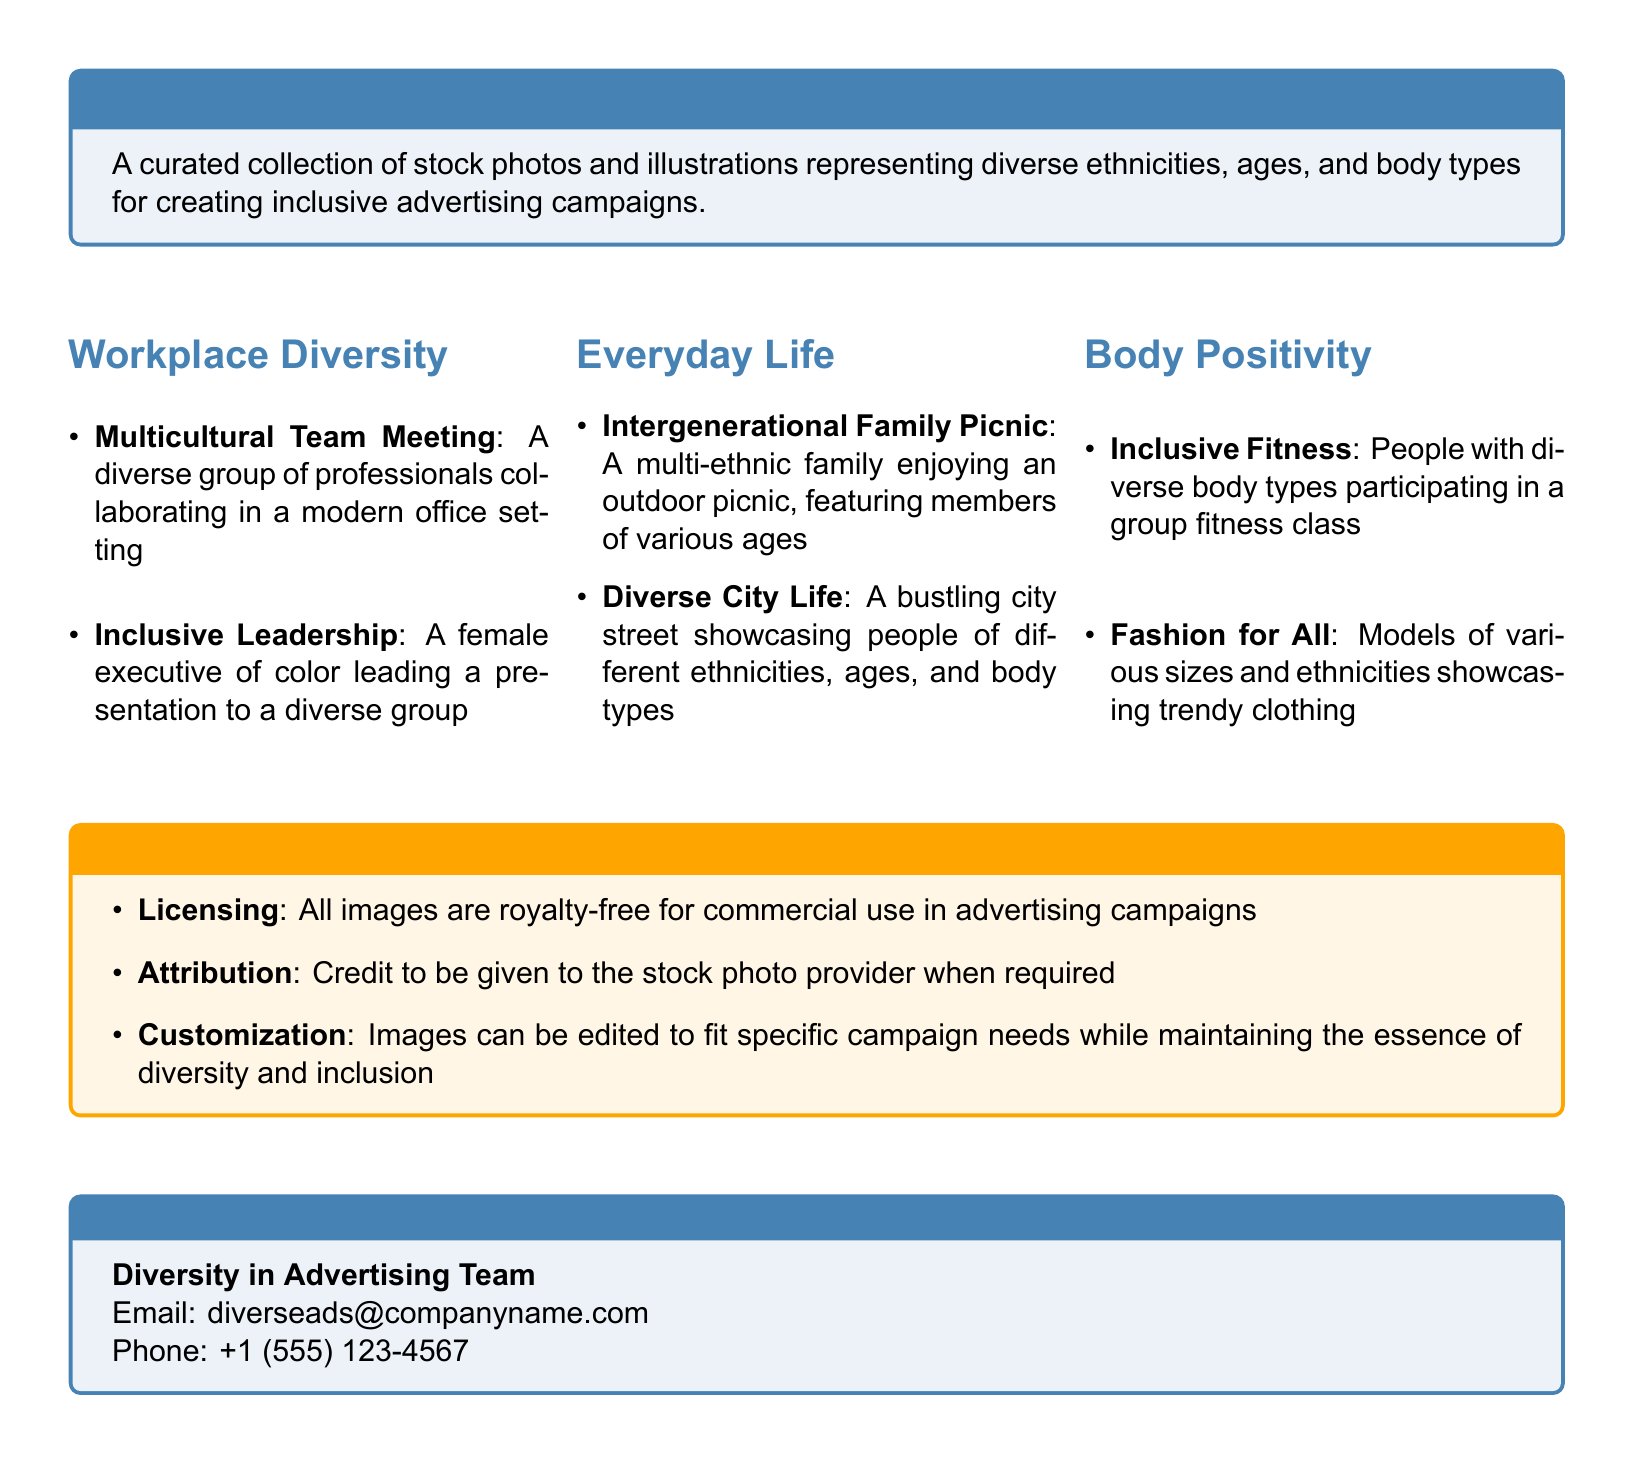What is the main theme of the catalog? The main theme is about representing diverse ethnicities, ages, and body types for advertising use.
Answer: Inclusive Imagery How many categories are listed in the document? The document lists three categories: Workplace Diversity, Everyday Life, and Body Positivity.
Answer: Three What type of meeting is illustrated in the Workplace Diversity section? The meeting type illustrated shows a diverse group collaborating in a modern office setting.
Answer: Multicultural Team Meeting What is one example of an image in the Body Positivity section? This question points to images that promote body positivity, showcasing diverse body types.
Answer: Inclusive Fitness What is the purpose of the Usage Guidelines section? This section outlines how the images can be used in advertising campaigns.
Answer: Licensing and Attribution What email address is provided for contact? This answer seeks specific contact information given in the document.
Answer: diverseads@companyname.com What must be given when required for image attribution? This question addresses the requirement for image attribution as stated in the guidelines.
Answer: Credit to the stock photo provider How can images be modified according to the guidelines? The question looks into customization aspects provided for use in campaigns.
Answer: Edited to fit specific campaign needs 